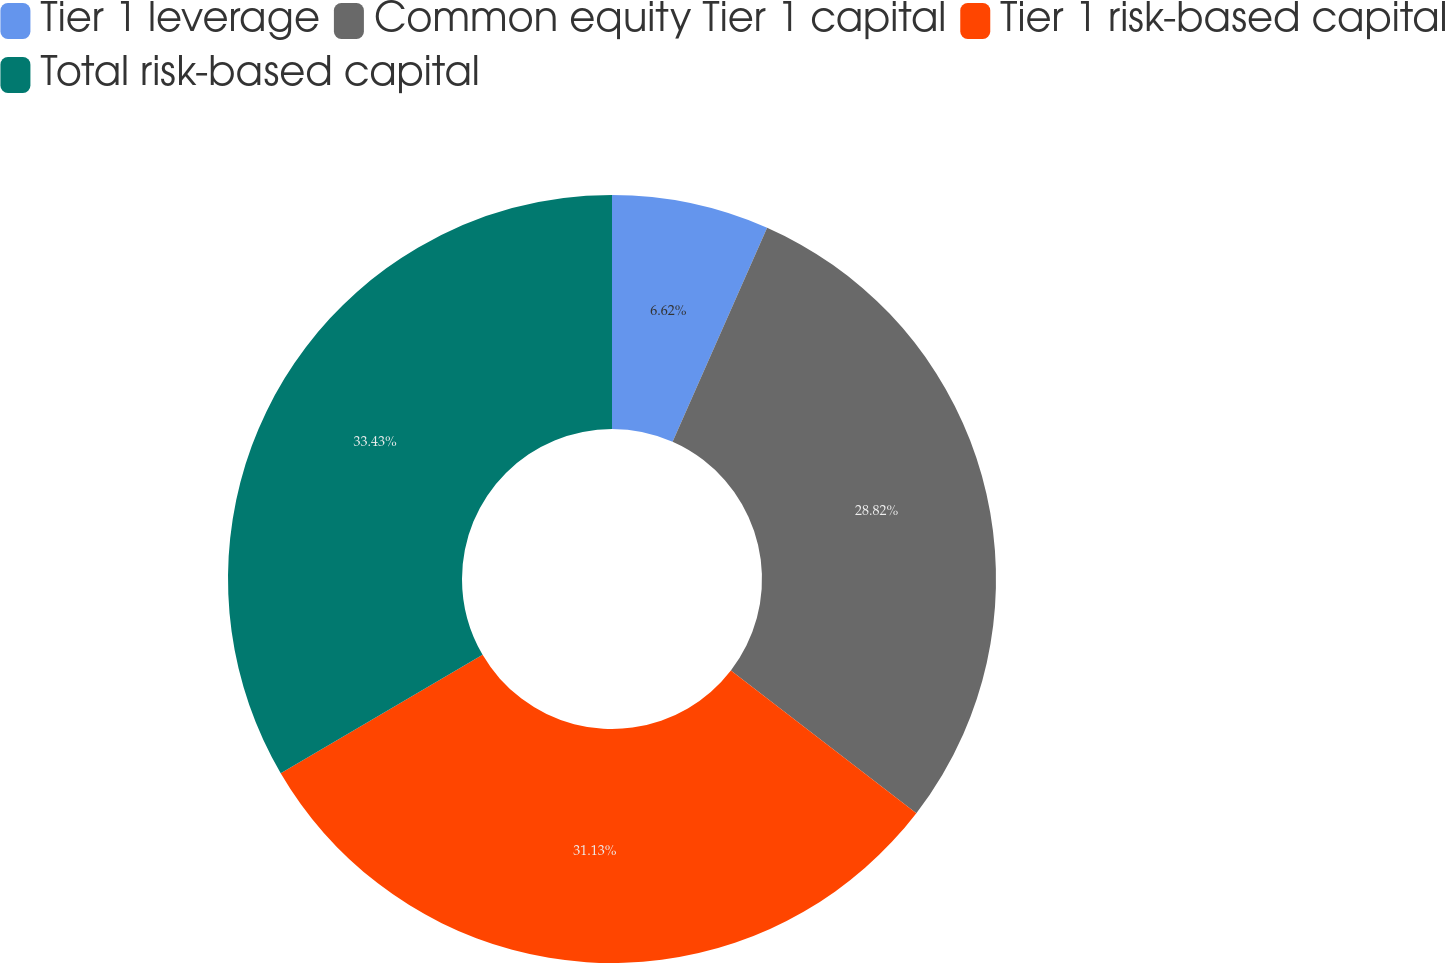<chart> <loc_0><loc_0><loc_500><loc_500><pie_chart><fcel>Tier 1 leverage<fcel>Common equity Tier 1 capital<fcel>Tier 1 risk-based capital<fcel>Total risk-based capital<nl><fcel>6.62%<fcel>28.82%<fcel>31.13%<fcel>33.44%<nl></chart> 